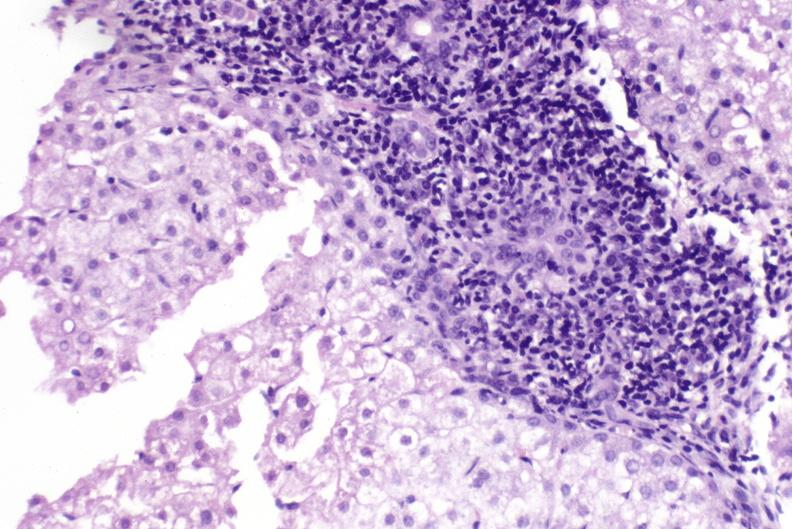what is present?
Answer the question using a single word or phrase. Liver 